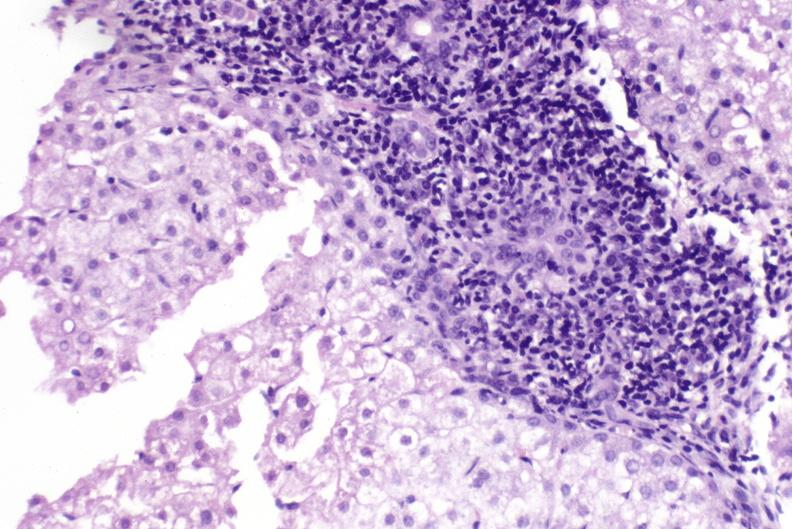what is present?
Answer the question using a single word or phrase. Liver 